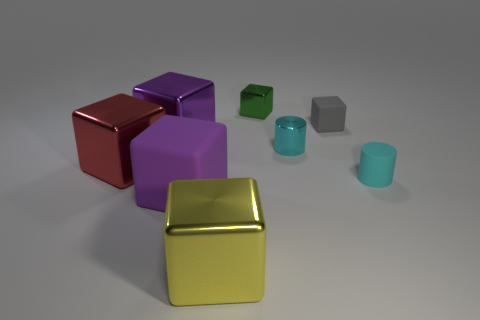What material is the tiny gray cube?
Ensure brevity in your answer.  Rubber. Are there any yellow things of the same size as the red metal cube?
Keep it short and to the point. Yes. There is a gray object that is the same size as the cyan matte cylinder; what material is it?
Your answer should be very brief. Rubber. How many big red metal objects are there?
Provide a succinct answer. 1. There is a block to the right of the green metal cube; how big is it?
Provide a succinct answer. Small. Are there an equal number of cyan metal objects that are left of the big red shiny cube and big purple balls?
Keep it short and to the point. Yes. Are there any large cyan rubber things that have the same shape as the large red metallic object?
Your answer should be compact. No. There is a thing that is both behind the large yellow object and in front of the cyan rubber thing; what shape is it?
Your answer should be compact. Cube. Is the yellow cube made of the same material as the purple cube that is behind the purple matte object?
Provide a succinct answer. Yes. There is a cyan rubber thing; are there any cylinders left of it?
Offer a very short reply. Yes. 